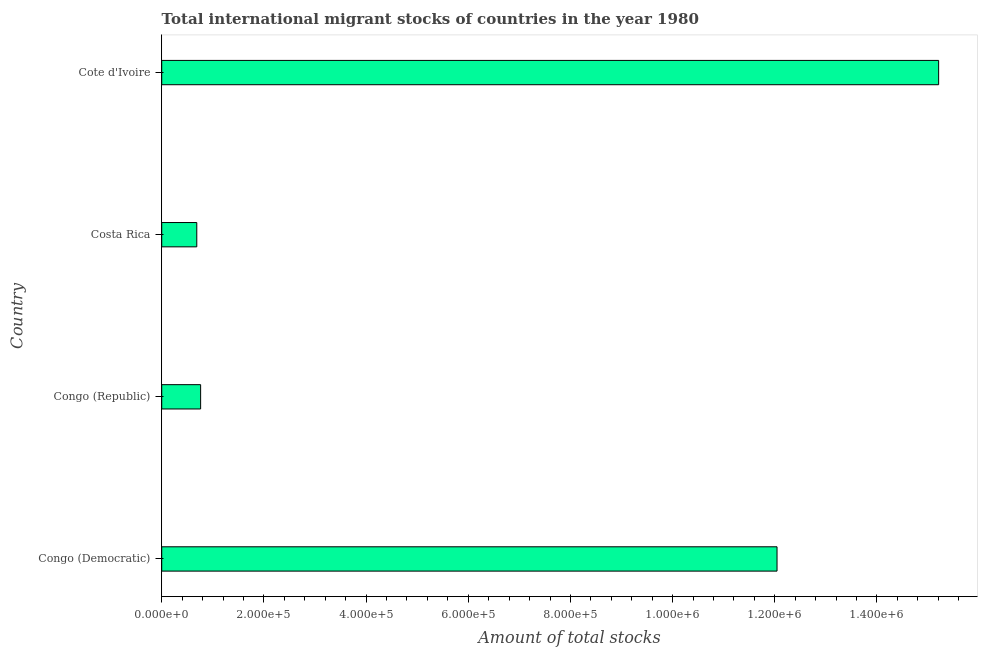Does the graph contain any zero values?
Give a very brief answer. No. Does the graph contain grids?
Your answer should be very brief. No. What is the title of the graph?
Your answer should be very brief. Total international migrant stocks of countries in the year 1980. What is the label or title of the X-axis?
Provide a succinct answer. Amount of total stocks. What is the total number of international migrant stock in Cote d'Ivoire?
Your response must be concise. 1.52e+06. Across all countries, what is the maximum total number of international migrant stock?
Ensure brevity in your answer.  1.52e+06. Across all countries, what is the minimum total number of international migrant stock?
Your response must be concise. 6.87e+04. In which country was the total number of international migrant stock maximum?
Give a very brief answer. Cote d'Ivoire. In which country was the total number of international migrant stock minimum?
Offer a very short reply. Costa Rica. What is the sum of the total number of international migrant stock?
Provide a succinct answer. 2.87e+06. What is the difference between the total number of international migrant stock in Congo (Democratic) and Cote d'Ivoire?
Give a very brief answer. -3.16e+05. What is the average total number of international migrant stock per country?
Make the answer very short. 7.17e+05. What is the median total number of international migrant stock?
Ensure brevity in your answer.  6.40e+05. In how many countries, is the total number of international migrant stock greater than 1280000 ?
Offer a very short reply. 1. What is the ratio of the total number of international migrant stock in Congo (Republic) to that in Costa Rica?
Offer a terse response. 1.11. What is the difference between the highest and the second highest total number of international migrant stock?
Offer a terse response. 3.16e+05. Is the sum of the total number of international migrant stock in Congo (Republic) and Costa Rica greater than the maximum total number of international migrant stock across all countries?
Your answer should be compact. No. What is the difference between the highest and the lowest total number of international migrant stock?
Keep it short and to the point. 1.45e+06. How many bars are there?
Your answer should be very brief. 4. Are all the bars in the graph horizontal?
Offer a very short reply. Yes. What is the Amount of total stocks in Congo (Democratic)?
Your response must be concise. 1.20e+06. What is the Amount of total stocks of Congo (Republic)?
Provide a short and direct response. 7.62e+04. What is the Amount of total stocks in Costa Rica?
Make the answer very short. 6.87e+04. What is the Amount of total stocks of Cote d'Ivoire?
Offer a very short reply. 1.52e+06. What is the difference between the Amount of total stocks in Congo (Democratic) and Congo (Republic)?
Give a very brief answer. 1.13e+06. What is the difference between the Amount of total stocks in Congo (Democratic) and Costa Rica?
Make the answer very short. 1.14e+06. What is the difference between the Amount of total stocks in Congo (Democratic) and Cote d'Ivoire?
Your response must be concise. -3.16e+05. What is the difference between the Amount of total stocks in Congo (Republic) and Costa Rica?
Keep it short and to the point. 7515. What is the difference between the Amount of total stocks in Congo (Republic) and Cote d'Ivoire?
Keep it short and to the point. -1.44e+06. What is the difference between the Amount of total stocks in Costa Rica and Cote d'Ivoire?
Make the answer very short. -1.45e+06. What is the ratio of the Amount of total stocks in Congo (Democratic) to that in Congo (Republic)?
Ensure brevity in your answer.  15.81. What is the ratio of the Amount of total stocks in Congo (Democratic) to that in Costa Rica?
Keep it short and to the point. 17.54. What is the ratio of the Amount of total stocks in Congo (Democratic) to that in Cote d'Ivoire?
Provide a succinct answer. 0.79. What is the ratio of the Amount of total stocks in Congo (Republic) to that in Costa Rica?
Make the answer very short. 1.11. What is the ratio of the Amount of total stocks in Congo (Republic) to that in Cote d'Ivoire?
Your response must be concise. 0.05. What is the ratio of the Amount of total stocks in Costa Rica to that in Cote d'Ivoire?
Make the answer very short. 0.04. 